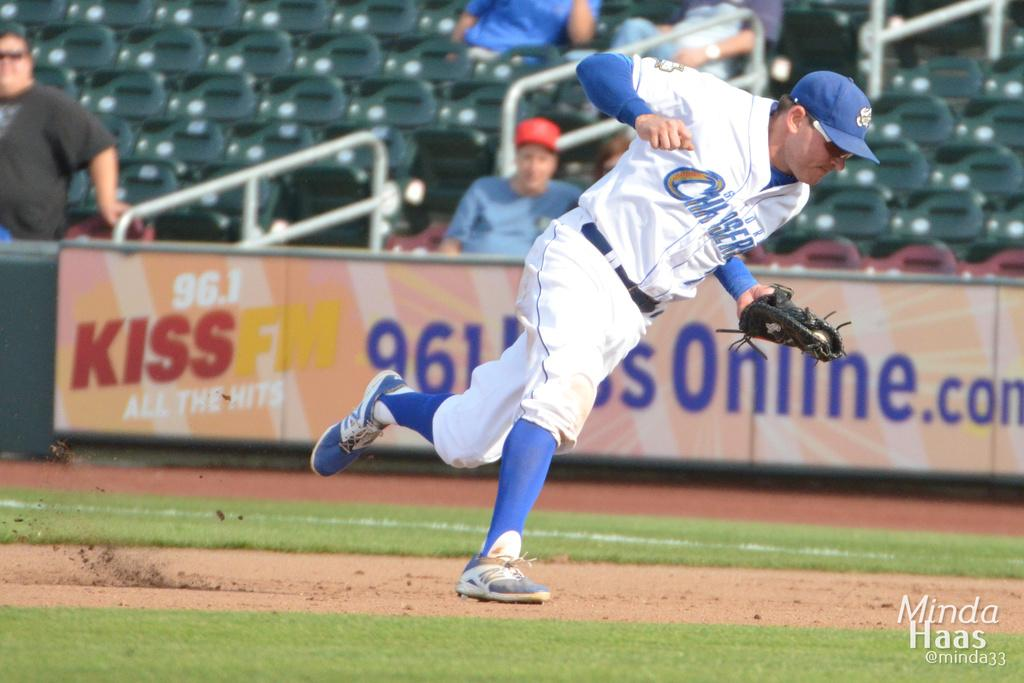<image>
Render a clear and concise summary of the photo. A Kiss FM billboard hangs at the edge of the ball field. 